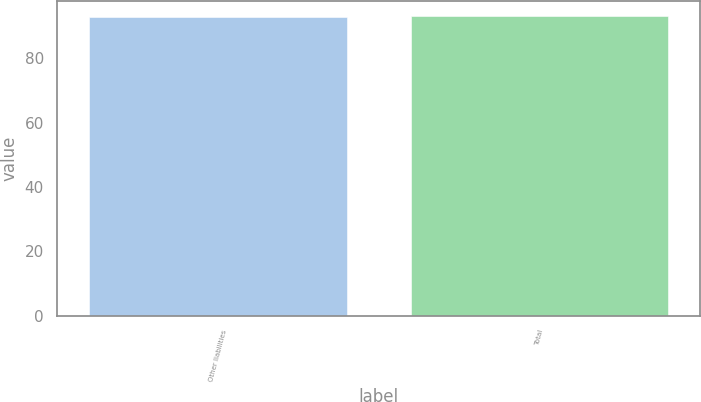Convert chart. <chart><loc_0><loc_0><loc_500><loc_500><bar_chart><fcel>Other liabilities<fcel>Total<nl><fcel>93<fcel>93.1<nl></chart> 